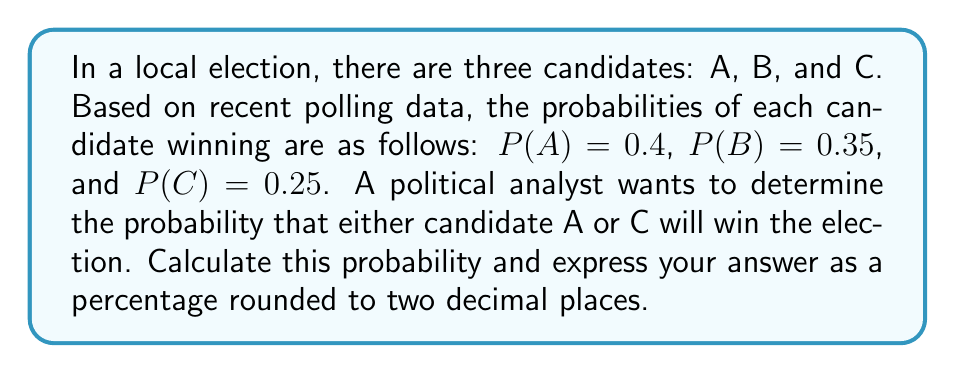Help me with this question. To solve this problem, we need to use the concept of probability theory, specifically the addition rule for mutually exclusive events. Since only one candidate can win the election, the events of A winning and C winning are mutually exclusive.

The probability of either A or C winning is the sum of their individual probabilities:

$$ P(A \text{ or } C) = P(A) + P(C) $$

Given:
$P(A) = 0.4$
$P(C) = 0.25$

Substituting these values into the equation:

$$ P(A \text{ or } C) = 0.4 + 0.25 = 0.65 $$

To express this as a percentage rounded to two decimal places, we multiply by 100 and round:

$$ 0.65 \times 100 = 65\% $$

Therefore, the probability that either candidate A or C will win the election is 65.00%.

This type of calculation is crucial for political analysts and career counselors specializing in political science to provide informed guidance to students interested in election forecasting and political strategy.
Answer: 65.00% 